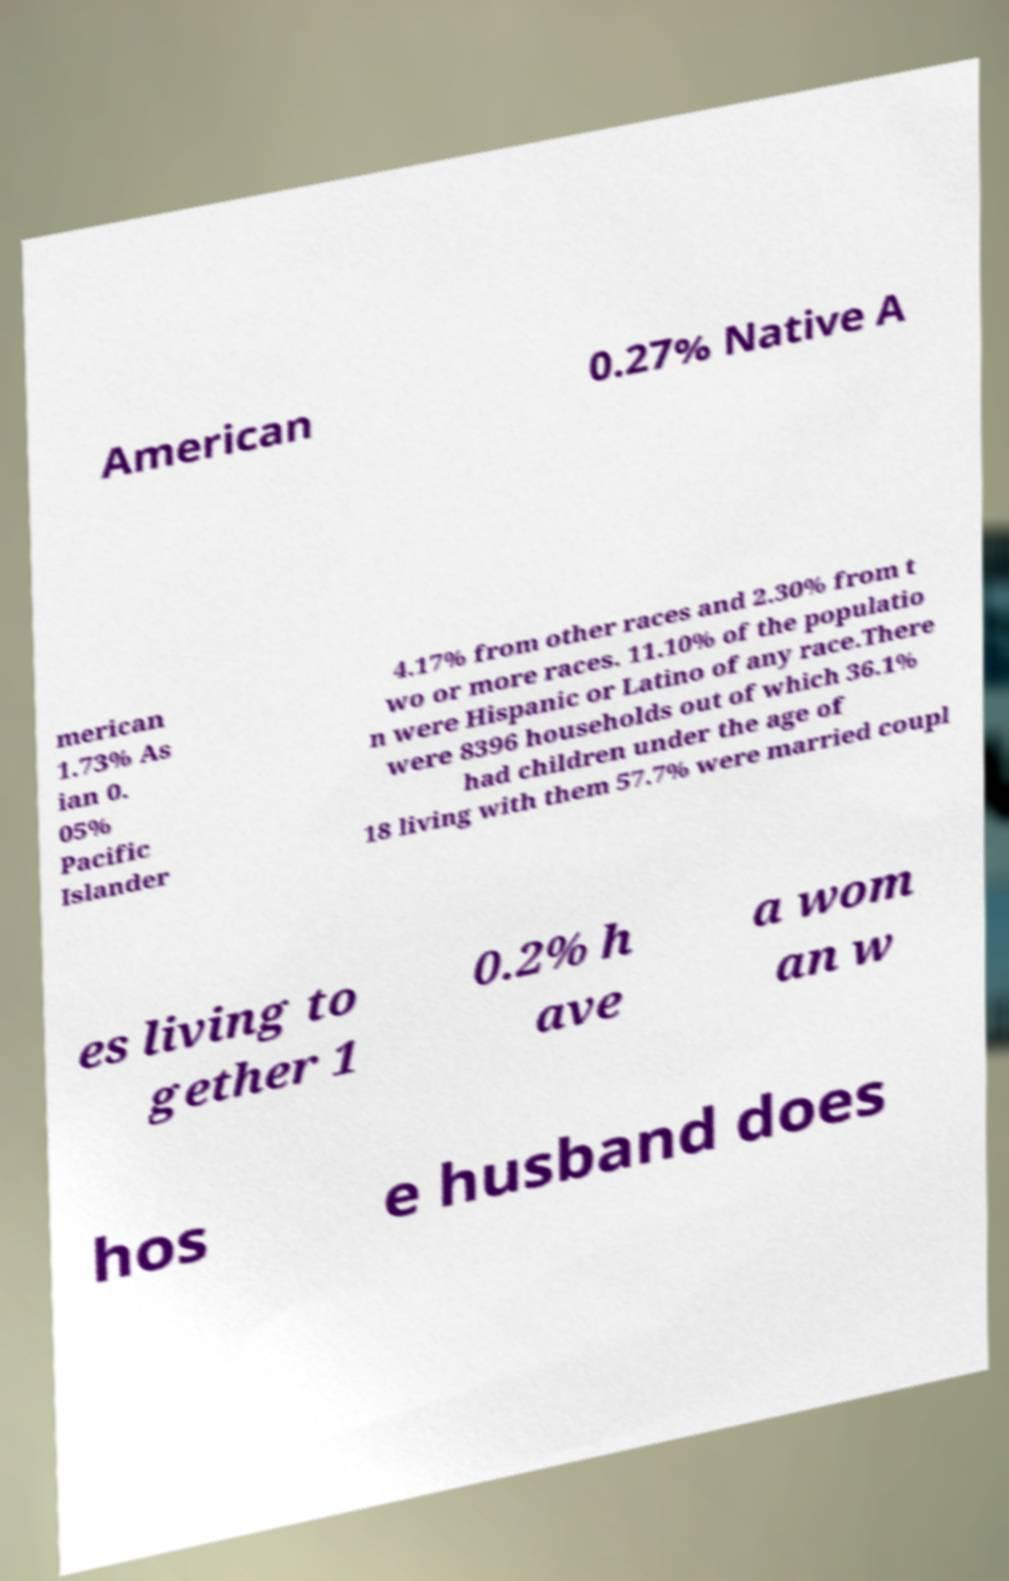Please read and relay the text visible in this image. What does it say? American 0.27% Native A merican 1.73% As ian 0. 05% Pacific Islander 4.17% from other races and 2.30% from t wo or more races. 11.10% of the populatio n were Hispanic or Latino of any race.There were 8396 households out of which 36.1% had children under the age of 18 living with them 57.7% were married coupl es living to gether 1 0.2% h ave a wom an w hos e husband does 